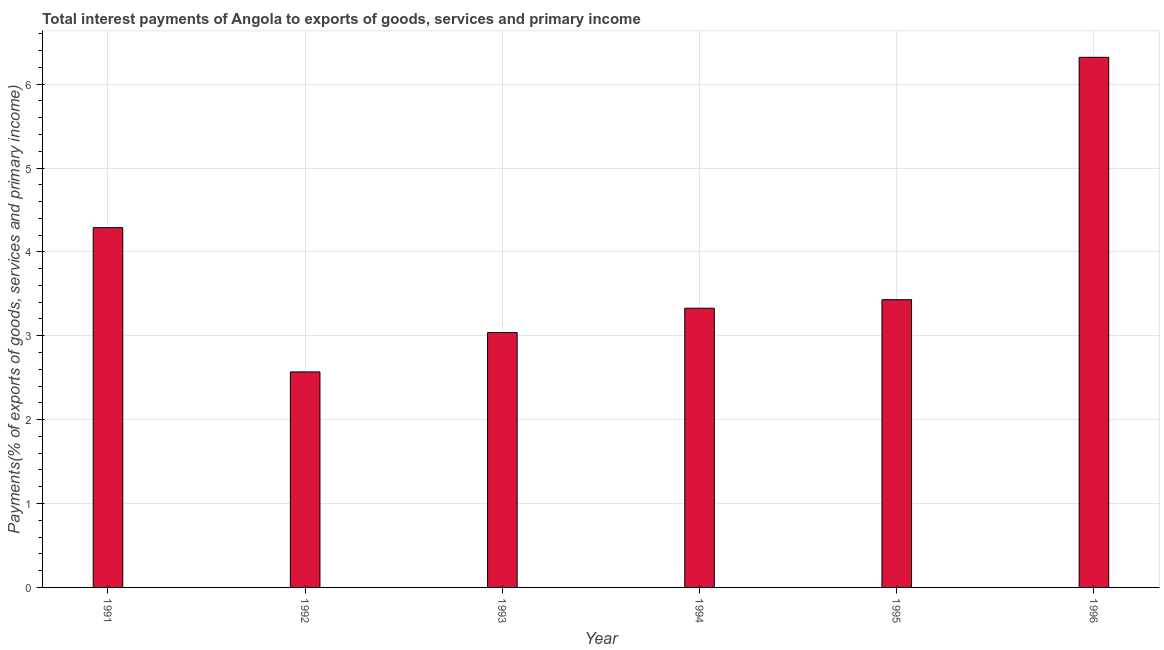What is the title of the graph?
Provide a succinct answer. Total interest payments of Angola to exports of goods, services and primary income. What is the label or title of the X-axis?
Offer a terse response. Year. What is the label or title of the Y-axis?
Keep it short and to the point. Payments(% of exports of goods, services and primary income). What is the total interest payments on external debt in 1994?
Offer a very short reply. 3.33. Across all years, what is the maximum total interest payments on external debt?
Offer a terse response. 6.32. Across all years, what is the minimum total interest payments on external debt?
Your answer should be very brief. 2.57. In which year was the total interest payments on external debt maximum?
Give a very brief answer. 1996. What is the sum of the total interest payments on external debt?
Your answer should be compact. 22.97. What is the difference between the total interest payments on external debt in 1994 and 1995?
Keep it short and to the point. -0.1. What is the average total interest payments on external debt per year?
Offer a very short reply. 3.83. What is the median total interest payments on external debt?
Offer a very short reply. 3.38. In how many years, is the total interest payments on external debt greater than 2.4 %?
Ensure brevity in your answer.  6. Do a majority of the years between 1992 and 1995 (inclusive) have total interest payments on external debt greater than 1.8 %?
Ensure brevity in your answer.  Yes. What is the ratio of the total interest payments on external debt in 1993 to that in 1995?
Offer a terse response. 0.89. Is the total interest payments on external debt in 1993 less than that in 1996?
Provide a succinct answer. Yes. What is the difference between the highest and the second highest total interest payments on external debt?
Your response must be concise. 2.03. Is the sum of the total interest payments on external debt in 1991 and 1996 greater than the maximum total interest payments on external debt across all years?
Give a very brief answer. Yes. What is the difference between the highest and the lowest total interest payments on external debt?
Ensure brevity in your answer.  3.75. Are the values on the major ticks of Y-axis written in scientific E-notation?
Offer a terse response. No. What is the Payments(% of exports of goods, services and primary income) of 1991?
Keep it short and to the point. 4.29. What is the Payments(% of exports of goods, services and primary income) in 1992?
Offer a terse response. 2.57. What is the Payments(% of exports of goods, services and primary income) of 1993?
Offer a terse response. 3.04. What is the Payments(% of exports of goods, services and primary income) in 1994?
Provide a succinct answer. 3.33. What is the Payments(% of exports of goods, services and primary income) of 1995?
Offer a terse response. 3.43. What is the Payments(% of exports of goods, services and primary income) in 1996?
Your answer should be very brief. 6.32. What is the difference between the Payments(% of exports of goods, services and primary income) in 1991 and 1992?
Ensure brevity in your answer.  1.72. What is the difference between the Payments(% of exports of goods, services and primary income) in 1991 and 1993?
Your answer should be compact. 1.25. What is the difference between the Payments(% of exports of goods, services and primary income) in 1991 and 1994?
Make the answer very short. 0.96. What is the difference between the Payments(% of exports of goods, services and primary income) in 1991 and 1995?
Your response must be concise. 0.86. What is the difference between the Payments(% of exports of goods, services and primary income) in 1991 and 1996?
Provide a short and direct response. -2.03. What is the difference between the Payments(% of exports of goods, services and primary income) in 1992 and 1993?
Keep it short and to the point. -0.47. What is the difference between the Payments(% of exports of goods, services and primary income) in 1992 and 1994?
Your response must be concise. -0.76. What is the difference between the Payments(% of exports of goods, services and primary income) in 1992 and 1995?
Make the answer very short. -0.86. What is the difference between the Payments(% of exports of goods, services and primary income) in 1992 and 1996?
Give a very brief answer. -3.75. What is the difference between the Payments(% of exports of goods, services and primary income) in 1993 and 1994?
Offer a very short reply. -0.29. What is the difference between the Payments(% of exports of goods, services and primary income) in 1993 and 1995?
Offer a very short reply. -0.39. What is the difference between the Payments(% of exports of goods, services and primary income) in 1993 and 1996?
Provide a short and direct response. -3.28. What is the difference between the Payments(% of exports of goods, services and primary income) in 1994 and 1995?
Ensure brevity in your answer.  -0.1. What is the difference between the Payments(% of exports of goods, services and primary income) in 1994 and 1996?
Offer a terse response. -2.99. What is the difference between the Payments(% of exports of goods, services and primary income) in 1995 and 1996?
Provide a succinct answer. -2.89. What is the ratio of the Payments(% of exports of goods, services and primary income) in 1991 to that in 1992?
Make the answer very short. 1.67. What is the ratio of the Payments(% of exports of goods, services and primary income) in 1991 to that in 1993?
Provide a short and direct response. 1.41. What is the ratio of the Payments(% of exports of goods, services and primary income) in 1991 to that in 1994?
Provide a short and direct response. 1.29. What is the ratio of the Payments(% of exports of goods, services and primary income) in 1991 to that in 1996?
Give a very brief answer. 0.68. What is the ratio of the Payments(% of exports of goods, services and primary income) in 1992 to that in 1993?
Make the answer very short. 0.85. What is the ratio of the Payments(% of exports of goods, services and primary income) in 1992 to that in 1994?
Your answer should be compact. 0.77. What is the ratio of the Payments(% of exports of goods, services and primary income) in 1992 to that in 1995?
Give a very brief answer. 0.75. What is the ratio of the Payments(% of exports of goods, services and primary income) in 1992 to that in 1996?
Give a very brief answer. 0.41. What is the ratio of the Payments(% of exports of goods, services and primary income) in 1993 to that in 1995?
Your answer should be compact. 0.89. What is the ratio of the Payments(% of exports of goods, services and primary income) in 1993 to that in 1996?
Make the answer very short. 0.48. What is the ratio of the Payments(% of exports of goods, services and primary income) in 1994 to that in 1995?
Keep it short and to the point. 0.97. What is the ratio of the Payments(% of exports of goods, services and primary income) in 1994 to that in 1996?
Offer a very short reply. 0.53. What is the ratio of the Payments(% of exports of goods, services and primary income) in 1995 to that in 1996?
Keep it short and to the point. 0.54. 